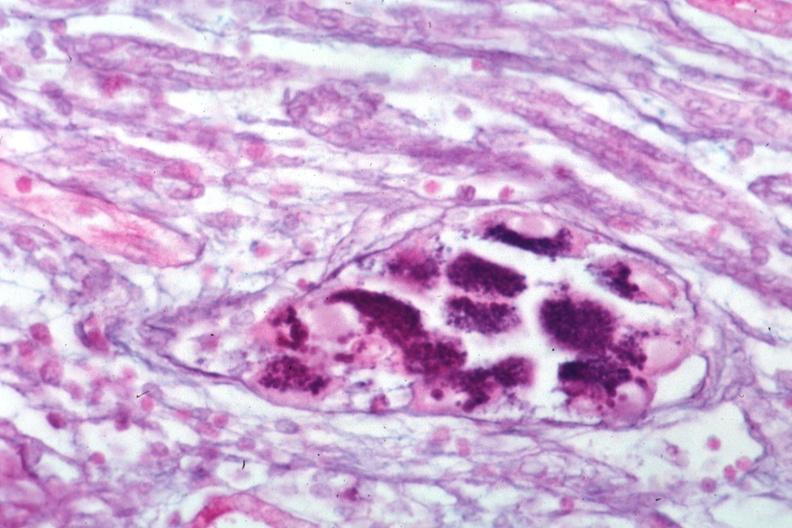does this image show pas-alcian blue?
Answer the question using a single word or phrase. Yes 